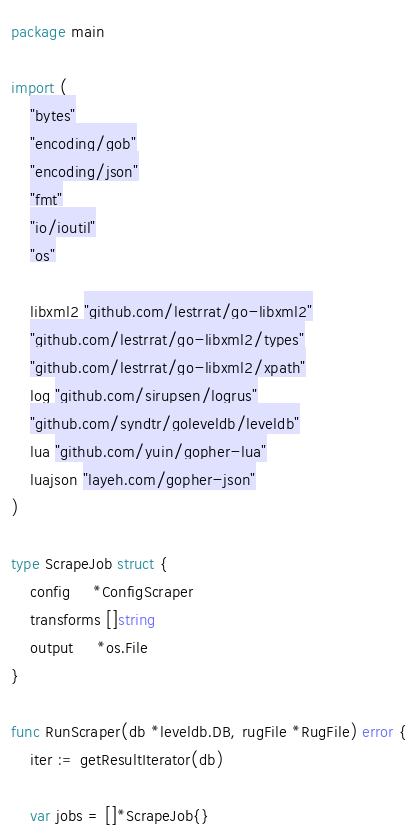<code> <loc_0><loc_0><loc_500><loc_500><_Go_>package main

import (
	"bytes"
	"encoding/gob"
	"encoding/json"
	"fmt"
	"io/ioutil"
	"os"

	libxml2 "github.com/lestrrat/go-libxml2"
	"github.com/lestrrat/go-libxml2/types"
	"github.com/lestrrat/go-libxml2/xpath"
	log "github.com/sirupsen/logrus"
	"github.com/syndtr/goleveldb/leveldb"
	lua "github.com/yuin/gopher-lua"
	luajson "layeh.com/gopher-json"
)

type ScrapeJob struct {
	config     *ConfigScraper
	transforms []string
	output     *os.File
}

func RunScraper(db *leveldb.DB, rugFile *RugFile) error {
	iter := getResultIterator(db)

	var jobs = []*ScrapeJob{}</code> 